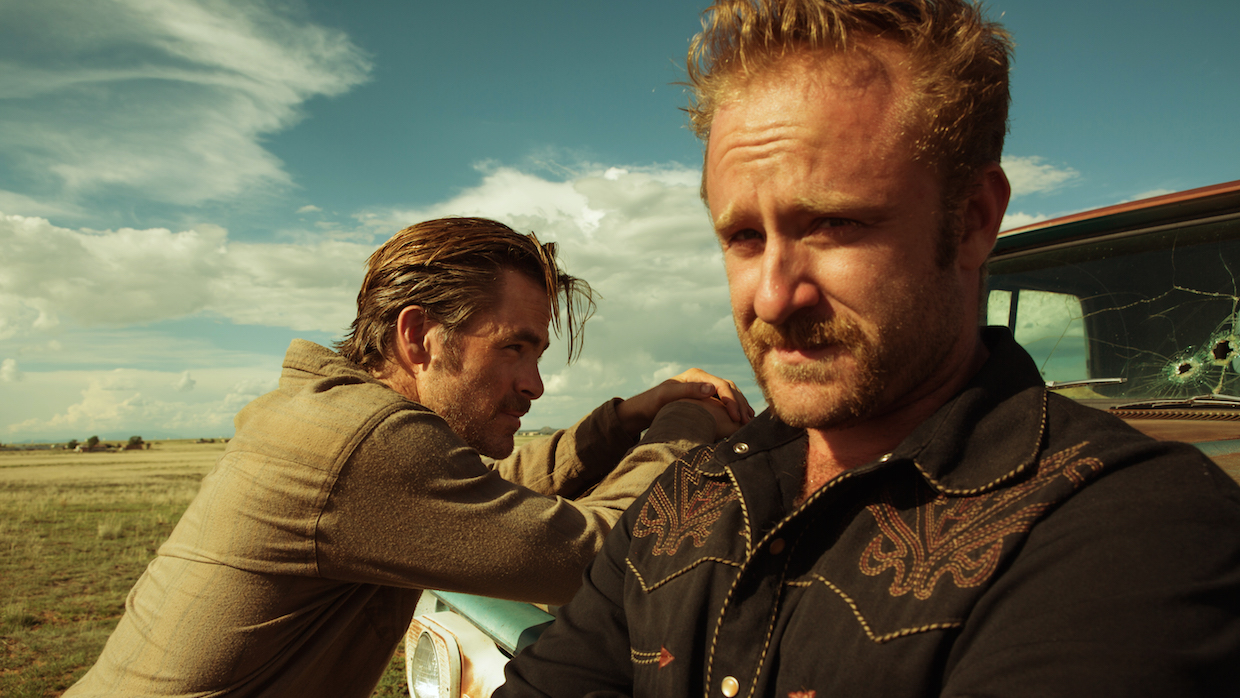What's the significance of the cracked windshield in the scene? The cracked windshield is likely a symbol of the character's tumultuous and dangerous journey. It hints at past violence or a recent confrontation, suggesting that the characters are dealing with the aftermath of a conflict. This detail helps to set the tone of desperation and intensity in the scene. How does the environment contribute to the mood of the image? The expansive, open landscape in the background contributes to a sense of isolation and desolation, amplifying the tension and ruggedness of the characters' situation. The wide sky with scattered clouds gives a sense of vastness, perhaps hinting at the endless challenges the characters face or a looming confrontation. This setting enhances the feeling of being on the run or in the midst of a high-stakes moment. 